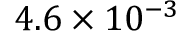Convert formula to latex. <formula><loc_0><loc_0><loc_500><loc_500>4 . 6 \times 1 0 ^ { - 3 }</formula> 